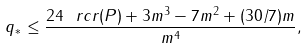<formula> <loc_0><loc_0><loc_500><loc_500>q _ { * } \leq \frac { 2 4 \ r c r ( P ) + 3 m ^ { 3 } - 7 m ^ { 2 } + ( 3 0 / 7 ) m } { m ^ { 4 } } ,</formula> 